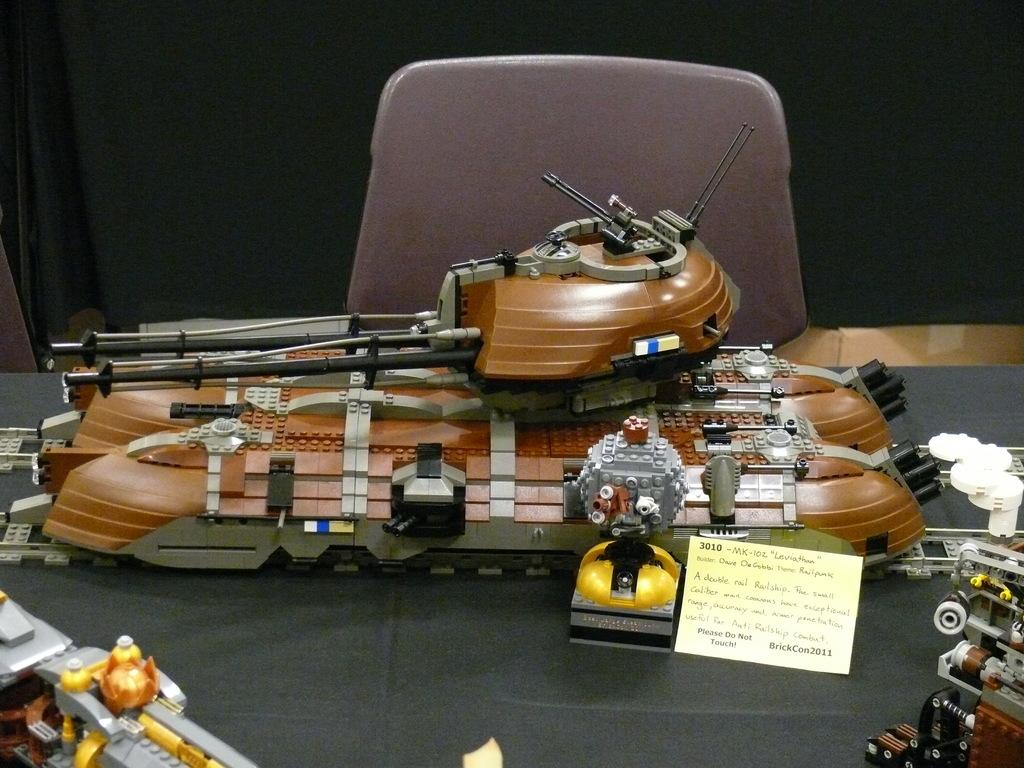What objects are on the table in the image? There are vehicle models on the table in the image. What type of furniture is visible in the image? There is a chair in the image. What type of window treatment is present in the image? There is a curtain in the image. What type of wine is being served at the competition in the image? There is no wine or competition present in the image; it features vehicle models on a table, a chair, and a curtain. 